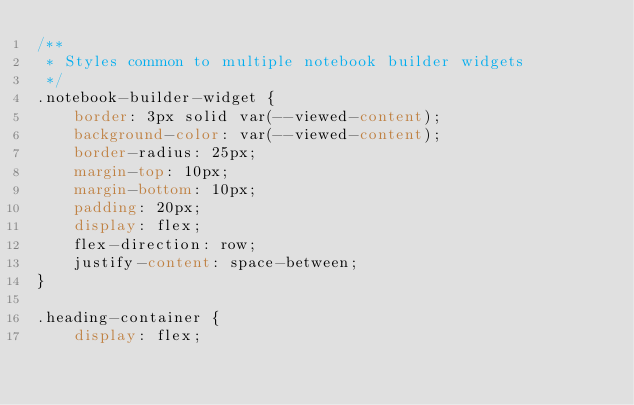Convert code to text. <code><loc_0><loc_0><loc_500><loc_500><_CSS_>/**
 * Styles common to multiple notebook builder widgets
 */
.notebook-builder-widget {
    border: 3px solid var(--viewed-content);
    background-color: var(--viewed-content);
    border-radius: 25px;
    margin-top: 10px;
    margin-bottom: 10px;
    padding: 20px;
    display: flex;
    flex-direction: row;
    justify-content: space-between;
}

.heading-container {
    display: flex;</code> 